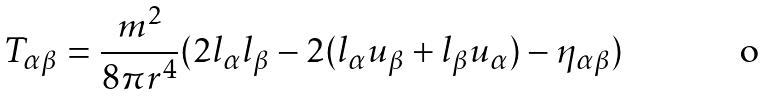Convert formula to latex. <formula><loc_0><loc_0><loc_500><loc_500>T _ { \alpha \beta } = \frac { m ^ { 2 } } { 8 \pi r ^ { 4 } } ( 2 l _ { \alpha } l _ { \beta } - 2 ( l _ { \alpha } u _ { \beta } + l _ { \beta } u _ { \alpha } ) - \eta _ { \alpha \beta } )</formula> 